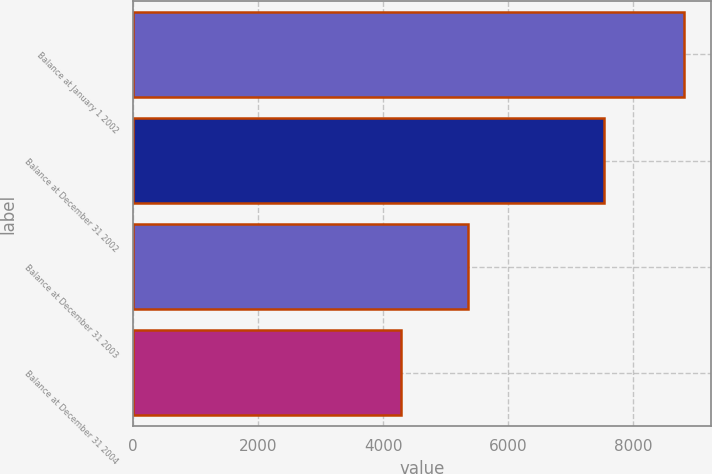Convert chart to OTSL. <chart><loc_0><loc_0><loc_500><loc_500><bar_chart><fcel>Balance at January 1 2002<fcel>Balance at December 31 2002<fcel>Balance at December 31 2003<fcel>Balance at December 31 2004<nl><fcel>8806<fcel>7538<fcel>5361<fcel>4281<nl></chart> 